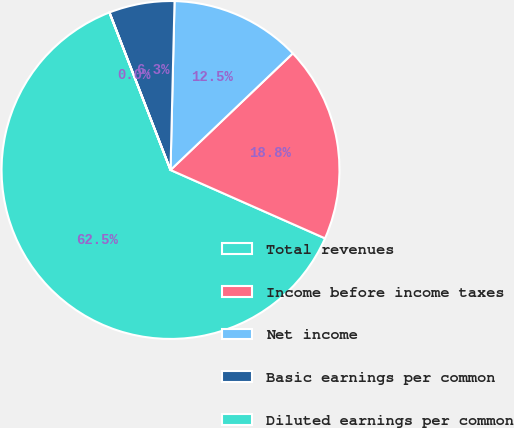Convert chart to OTSL. <chart><loc_0><loc_0><loc_500><loc_500><pie_chart><fcel>Total revenues<fcel>Income before income taxes<fcel>Net income<fcel>Basic earnings per common<fcel>Diluted earnings per common<nl><fcel>62.48%<fcel>18.75%<fcel>12.5%<fcel>6.26%<fcel>0.01%<nl></chart> 